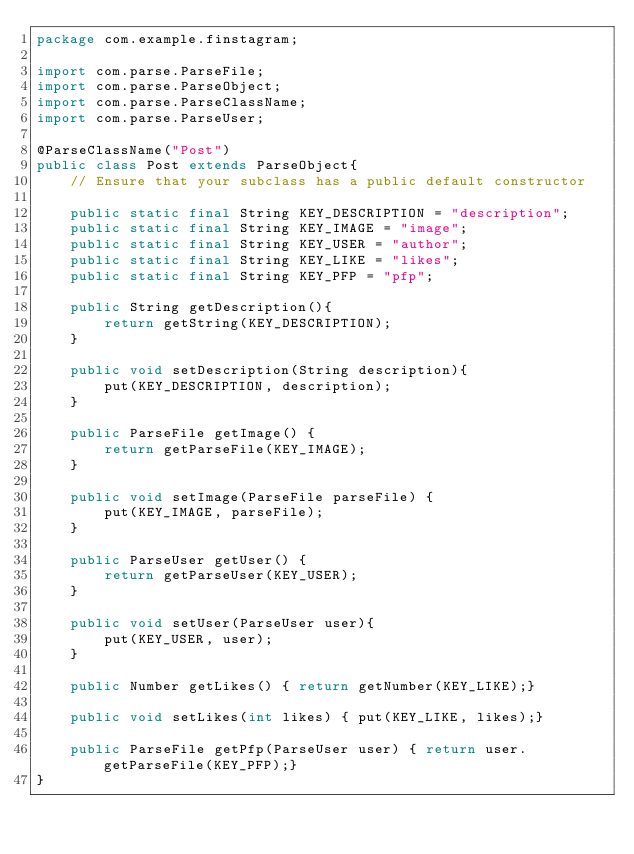Convert code to text. <code><loc_0><loc_0><loc_500><loc_500><_Java_>package com.example.finstagram;

import com.parse.ParseFile;
import com.parse.ParseObject;
import com.parse.ParseClassName;
import com.parse.ParseUser;

@ParseClassName("Post")
public class Post extends ParseObject{
    // Ensure that your subclass has a public default constructor

    public static final String KEY_DESCRIPTION = "description";
    public static final String KEY_IMAGE = "image";
    public static final String KEY_USER = "author";
    public static final String KEY_LIKE = "likes";
    public static final String KEY_PFP = "pfp";

    public String getDescription(){
        return getString(KEY_DESCRIPTION);
    }

    public void setDescription(String description){
        put(KEY_DESCRIPTION, description);
    }

    public ParseFile getImage() {
        return getParseFile(KEY_IMAGE);
    }

    public void setImage(ParseFile parseFile) {
        put(KEY_IMAGE, parseFile);
    }

    public ParseUser getUser() {
        return getParseUser(KEY_USER);
    }

    public void setUser(ParseUser user){
        put(KEY_USER, user);
    }

    public Number getLikes() { return getNumber(KEY_LIKE);}

    public void setLikes(int likes) { put(KEY_LIKE, likes);}

    public ParseFile getPfp(ParseUser user) { return user.getParseFile(KEY_PFP);}
}
</code> 